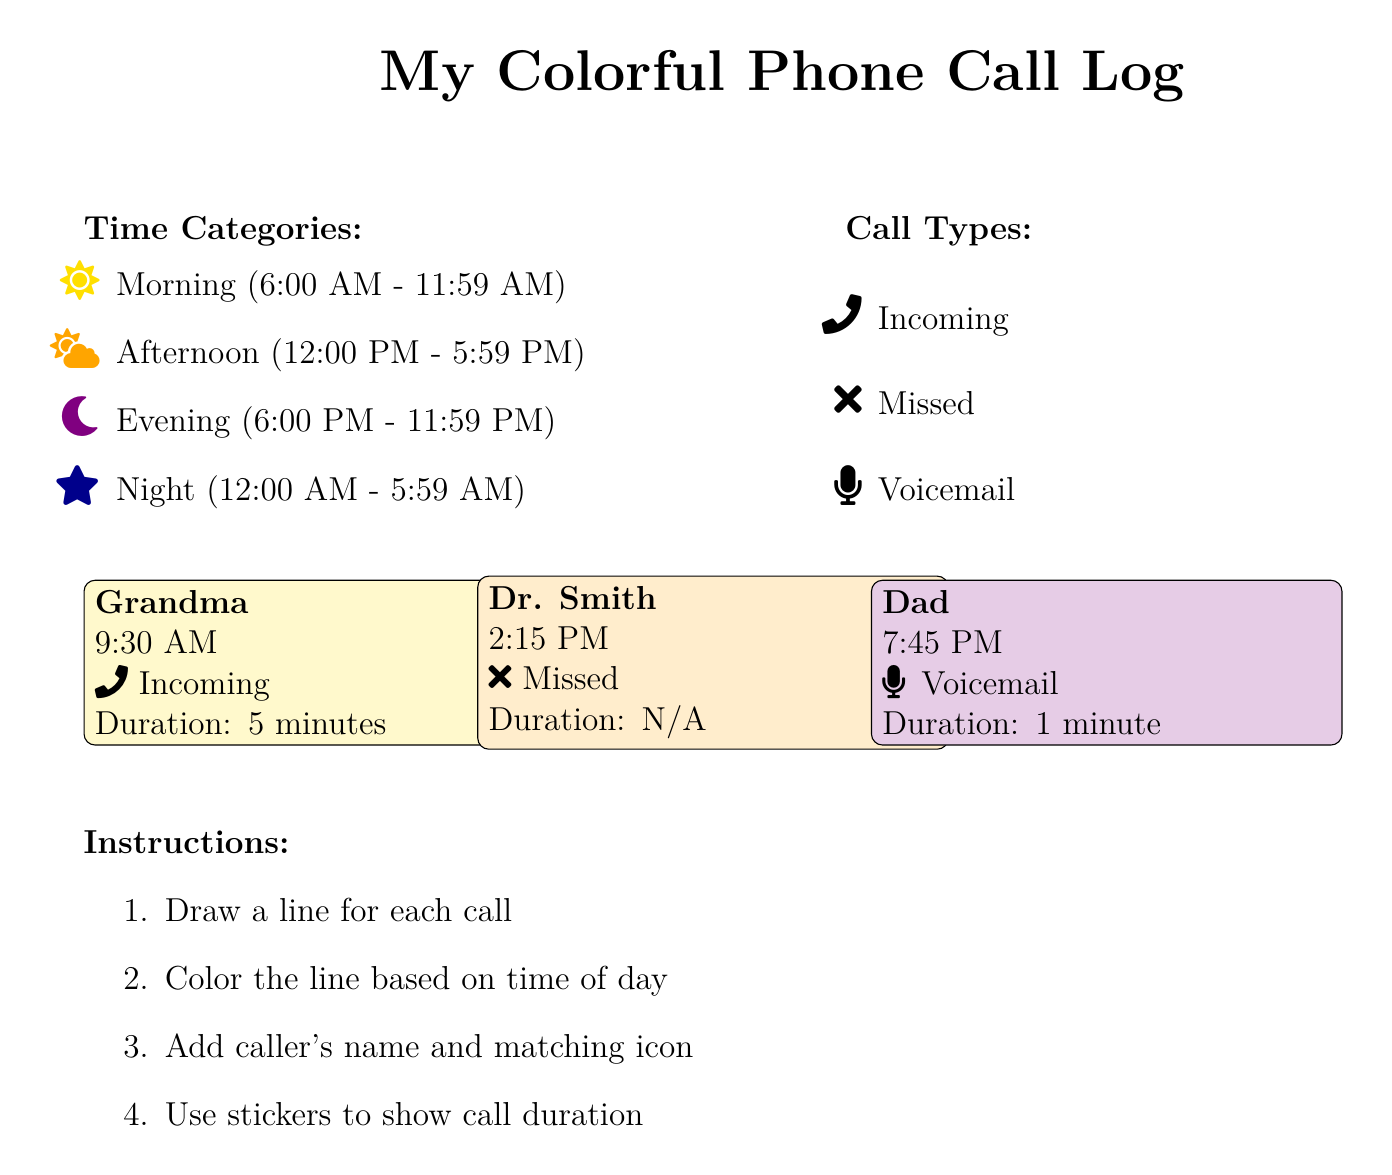What is the time of Grandma's call? Grandma's call is logged at 9:30 AM, which is indicated next to her name in the document.
Answer: 9:30 AM What type of call did Dr. Smith make? Dr. Smith's call is marked as missed, which is shown with a specific icon next to the details of the call.
Answer: Missed How long was Dad's voicemail? The duration of Dad's voicemail is provided as 1 minute in the call log.
Answer: 1 minute What color represents the evening time? The document specifies that the evening time is represented by purple, which is used for the call recorded at that time.
Answer: Purple How many incoming calls are listed? The document shows one incoming call from Grandma, indicating the number of incoming calls.
Answer: One What icon is used for a voicemail? A specific icon is used to represent voicemails, which is indicated next to Dad's call in the document.
Answer: Microphone What is the duration of Grandma's call? Grandma's call duration is stated as 5 minutes, which is included in her call log entry.
Answer: 5 minutes During which time category was Dr. Smith's call? Dr. Smith's call at 2:15 PM falls into the afternoon category as defined in the document.
Answer: Afternoon What indicator shows calls during the night? The night time calls are indicated by a dark blue color, which is described in the time categories section.
Answer: Dark blue 